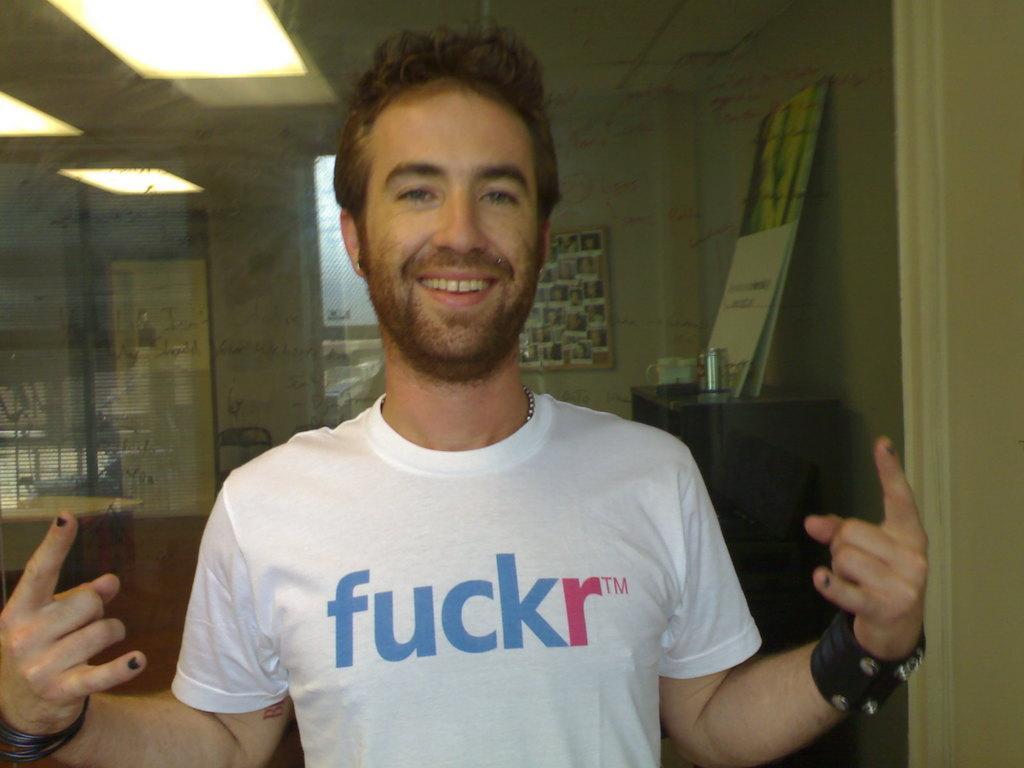Can you describe this image briefly? In this image we can see a man standing and in the background there is a table and on the table there are few objects and a poster and there is a picture frame to the wall and lights to the ceiling. 